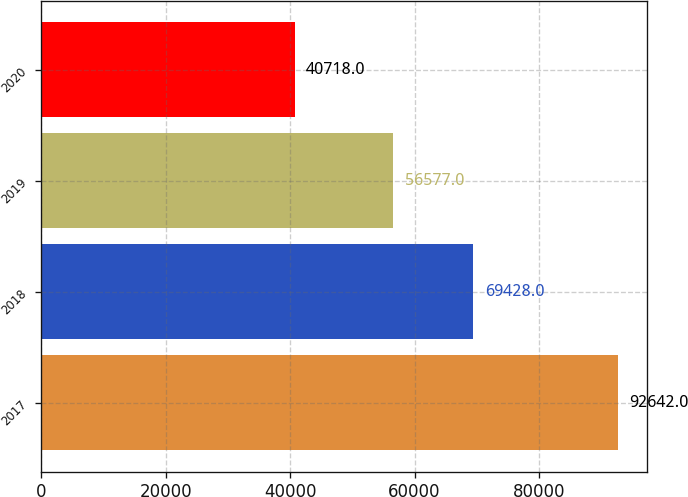Convert chart. <chart><loc_0><loc_0><loc_500><loc_500><bar_chart><fcel>2017<fcel>2018<fcel>2019<fcel>2020<nl><fcel>92642<fcel>69428<fcel>56577<fcel>40718<nl></chart> 